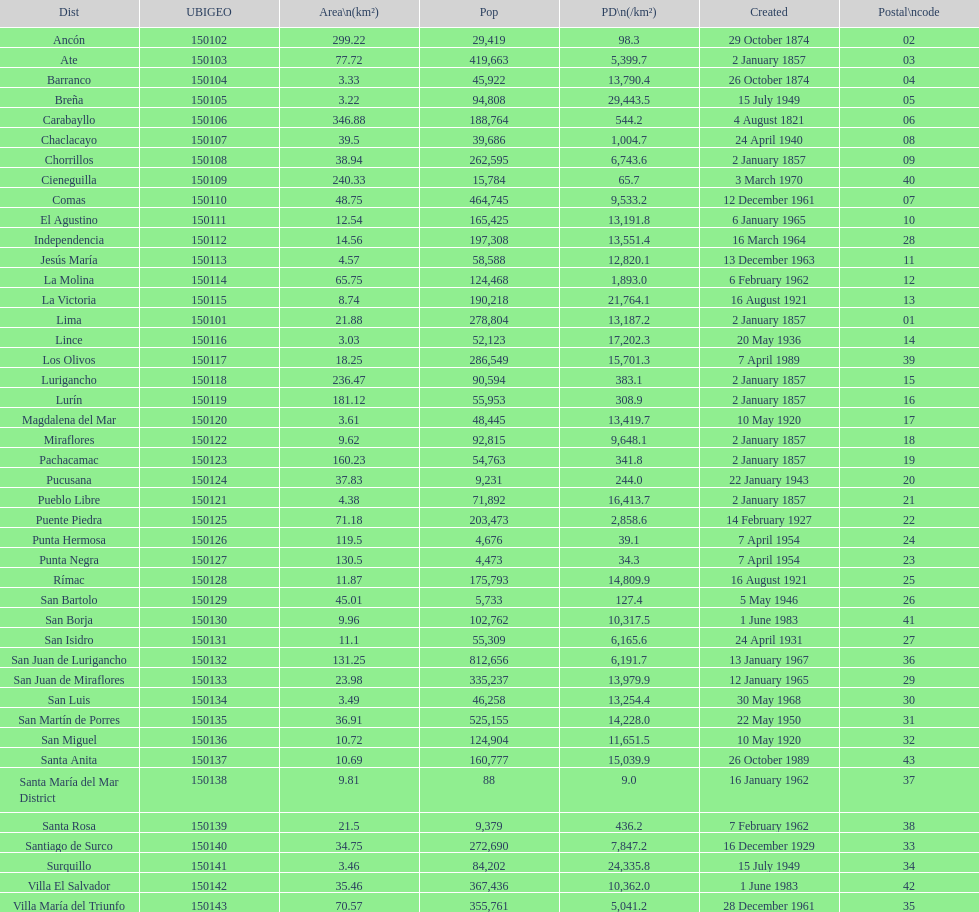How many districts have a population density of at lest 1000.0? 31. 